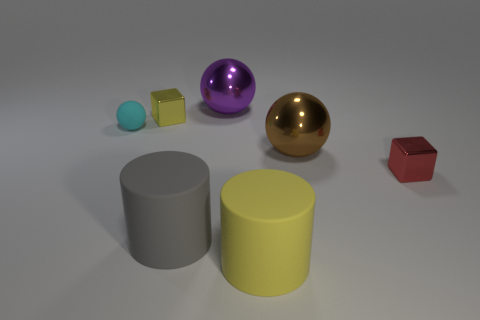Add 1 red cubes. How many objects exist? 8 Subtract all cylinders. How many objects are left? 5 Subtract all large cylinders. Subtract all small cyan cylinders. How many objects are left? 5 Add 1 purple metal balls. How many purple metal balls are left? 2 Add 3 large objects. How many large objects exist? 7 Subtract 1 yellow cylinders. How many objects are left? 6 